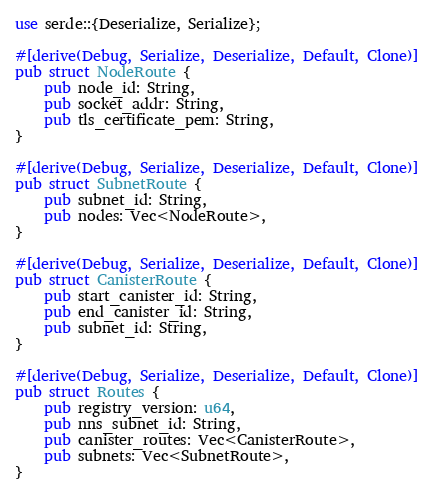<code> <loc_0><loc_0><loc_500><loc_500><_Rust_>use serde::{Deserialize, Serialize};

#[derive(Debug, Serialize, Deserialize, Default, Clone)]
pub struct NodeRoute {
    pub node_id: String,
    pub socket_addr: String,
    pub tls_certificate_pem: String,
}

#[derive(Debug, Serialize, Deserialize, Default, Clone)]
pub struct SubnetRoute {
    pub subnet_id: String,
    pub nodes: Vec<NodeRoute>,
}

#[derive(Debug, Serialize, Deserialize, Default, Clone)]
pub struct CanisterRoute {
    pub start_canister_id: String,
    pub end_canister_id: String,
    pub subnet_id: String,
}

#[derive(Debug, Serialize, Deserialize, Default, Clone)]
pub struct Routes {
    pub registry_version: u64,
    pub nns_subnet_id: String,
    pub canister_routes: Vec<CanisterRoute>,
    pub subnets: Vec<SubnetRoute>,
}
</code> 